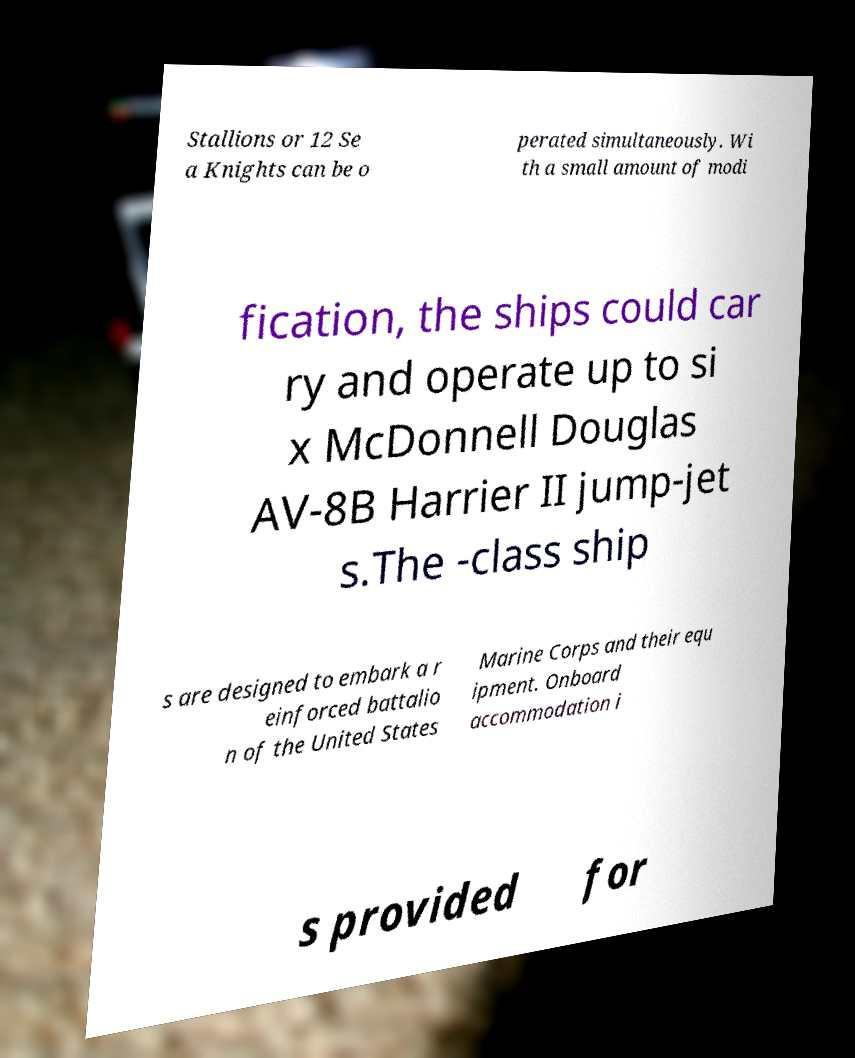Can you read and provide the text displayed in the image?This photo seems to have some interesting text. Can you extract and type it out for me? Stallions or 12 Se a Knights can be o perated simultaneously. Wi th a small amount of modi fication, the ships could car ry and operate up to si x McDonnell Douglas AV-8B Harrier II jump-jet s.The -class ship s are designed to embark a r einforced battalio n of the United States Marine Corps and their equ ipment. Onboard accommodation i s provided for 